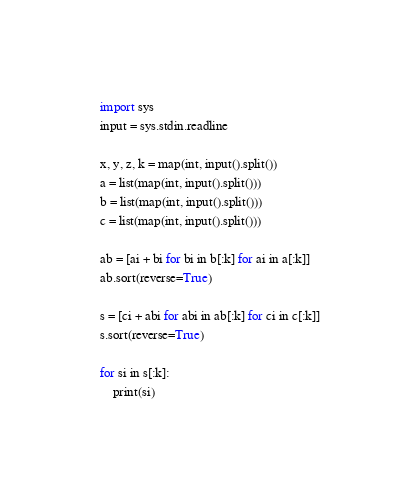Convert code to text. <code><loc_0><loc_0><loc_500><loc_500><_Python_>import sys
input = sys.stdin.readline

x, y, z, k = map(int, input().split())
a = list(map(int, input().split()))
b = list(map(int, input().split()))
c = list(map(int, input().split()))

ab = [ai + bi for bi in b[:k] for ai in a[:k]]
ab.sort(reverse=True)

s = [ci + abi for abi in ab[:k] for ci in c[:k]]
s.sort(reverse=True)

for si in s[:k]:
    print(si)</code> 